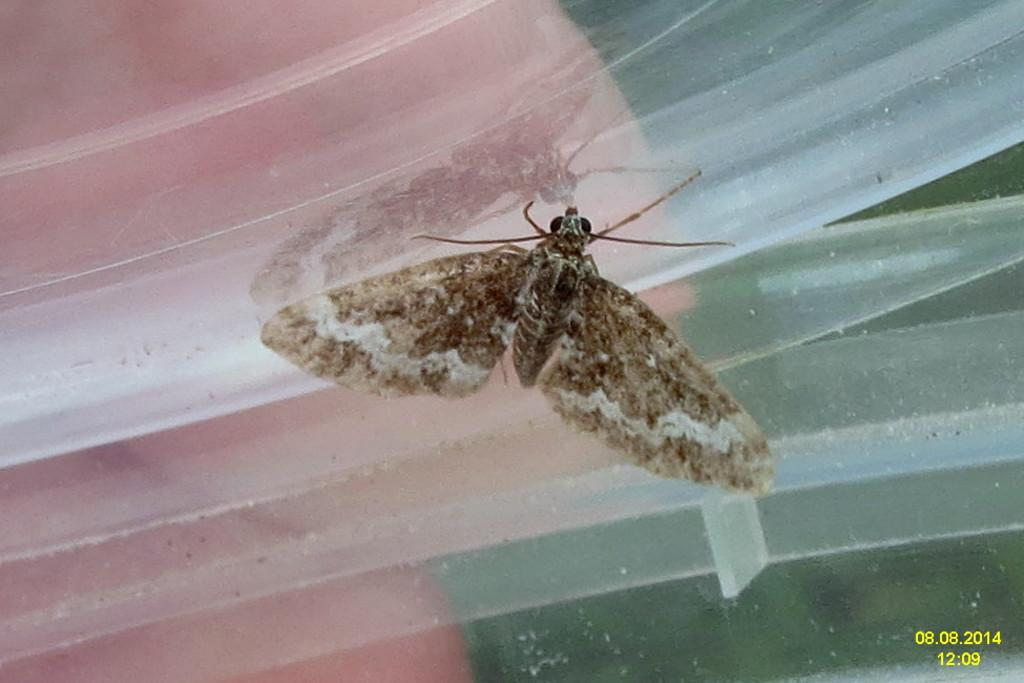What type of creature can be seen in the image? There is an insect in the image. Where is the insect located in the image? The insect is on an object. What type of cap is the cow wearing in the image? There is no cap or cow present in the image; it only features an insect on an object. 